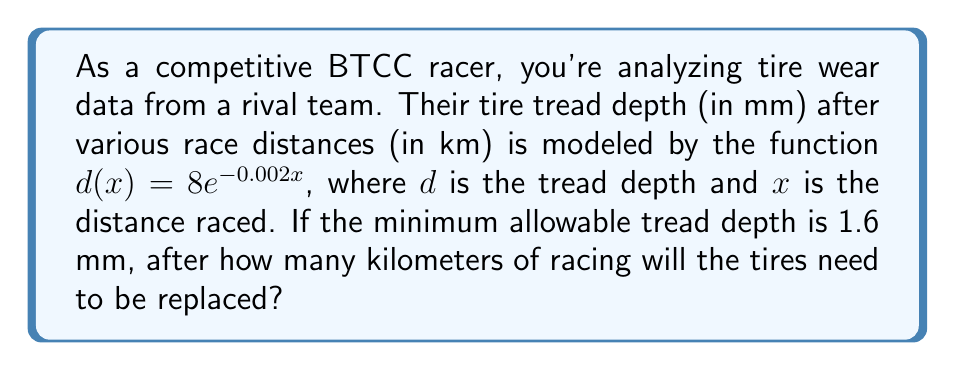What is the answer to this math problem? To solve this problem, we need to use the given exponential function and solve for $x$ when $d(x) = 1.6$ mm. Let's break it down step-by-step:

1) We start with the equation: $d(x) = 8e^{-0.002x}$

2) We want to find $x$ when $d(x) = 1.6$, so we set up the equation:
   $1.6 = 8e^{-0.002x}$

3) Divide both sides by 8:
   $\frac{1.6}{8} = e^{-0.002x}$
   $0.2 = e^{-0.002x}$

4) Take the natural logarithm of both sides:
   $\ln(0.2) = \ln(e^{-0.002x})$
   $\ln(0.2) = -0.002x$

5) Divide both sides by -0.002:
   $\frac{\ln(0.2)}{-0.002} = x$

6) Calculate the value:
   $x \approx 804.7$ km

Therefore, the tires will need to be replaced after approximately 804.7 km of racing.
Answer: $804.7$ km 